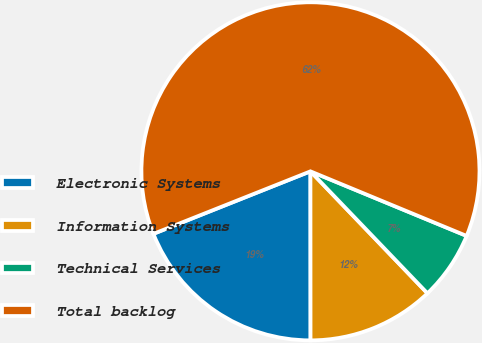Convert chart to OTSL. <chart><loc_0><loc_0><loc_500><loc_500><pie_chart><fcel>Electronic Systems<fcel>Information Systems<fcel>Technical Services<fcel>Total backlog<nl><fcel>18.98%<fcel>12.16%<fcel>6.59%<fcel>62.27%<nl></chart> 